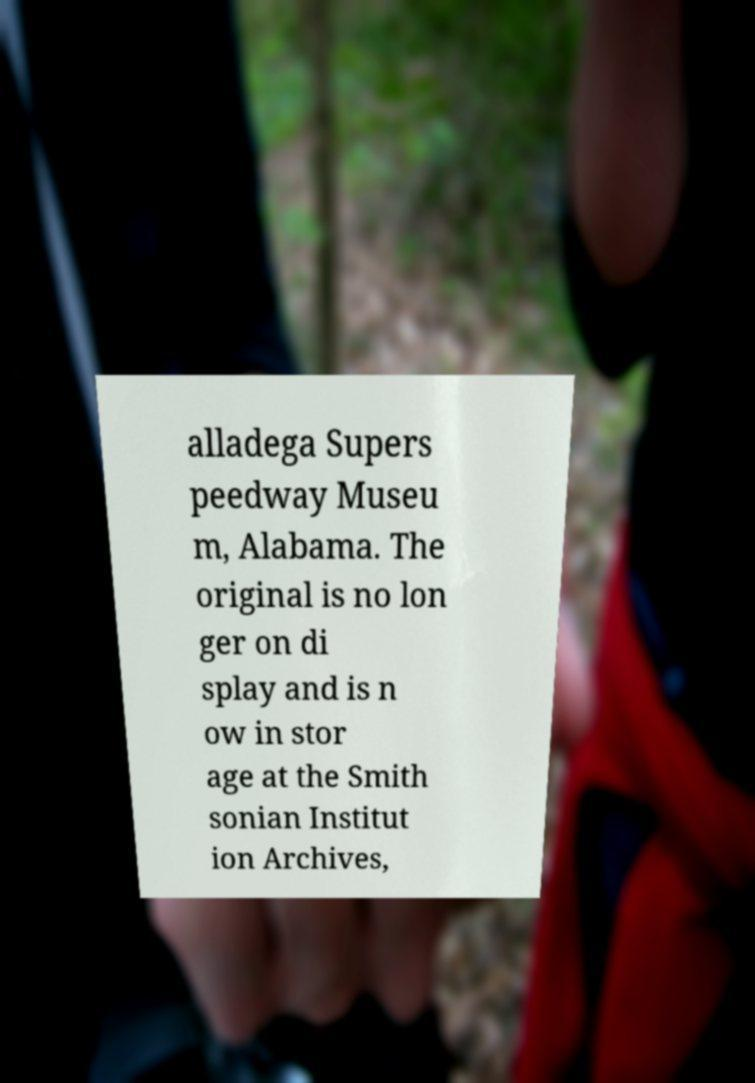Could you assist in decoding the text presented in this image and type it out clearly? alladega Supers peedway Museu m, Alabama. The original is no lon ger on di splay and is n ow in stor age at the Smith sonian Institut ion Archives, 